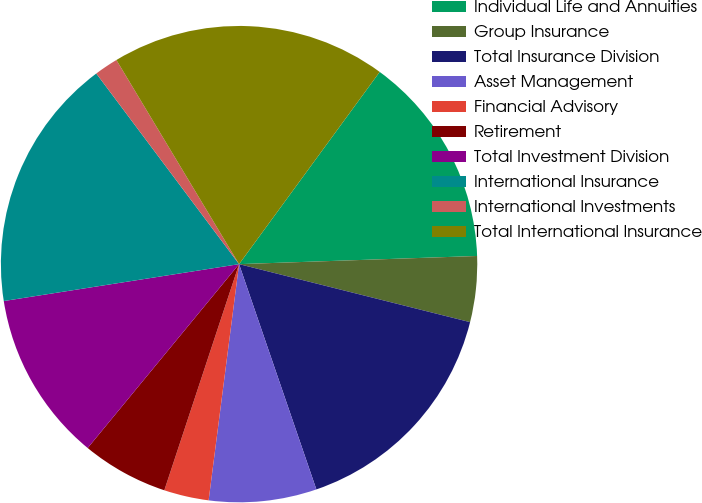Convert chart to OTSL. <chart><loc_0><loc_0><loc_500><loc_500><pie_chart><fcel>Individual Life and Annuities<fcel>Group Insurance<fcel>Total Insurance Division<fcel>Asset Management<fcel>Financial Advisory<fcel>Retirement<fcel>Total Investment Division<fcel>International Insurance<fcel>International Investments<fcel>Total International Insurance<nl><fcel>14.4%<fcel>4.46%<fcel>15.82%<fcel>7.3%<fcel>3.04%<fcel>5.88%<fcel>11.56%<fcel>17.24%<fcel>1.62%<fcel>18.66%<nl></chart> 